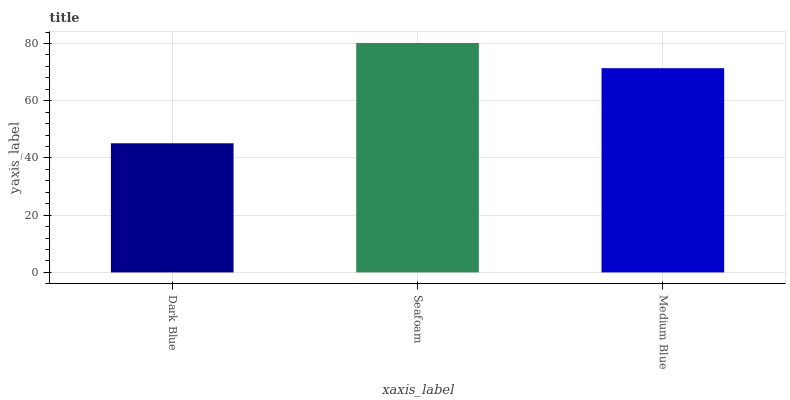Is Dark Blue the minimum?
Answer yes or no. Yes. Is Seafoam the maximum?
Answer yes or no. Yes. Is Medium Blue the minimum?
Answer yes or no. No. Is Medium Blue the maximum?
Answer yes or no. No. Is Seafoam greater than Medium Blue?
Answer yes or no. Yes. Is Medium Blue less than Seafoam?
Answer yes or no. Yes. Is Medium Blue greater than Seafoam?
Answer yes or no. No. Is Seafoam less than Medium Blue?
Answer yes or no. No. Is Medium Blue the high median?
Answer yes or no. Yes. Is Medium Blue the low median?
Answer yes or no. Yes. Is Dark Blue the high median?
Answer yes or no. No. Is Seafoam the low median?
Answer yes or no. No. 